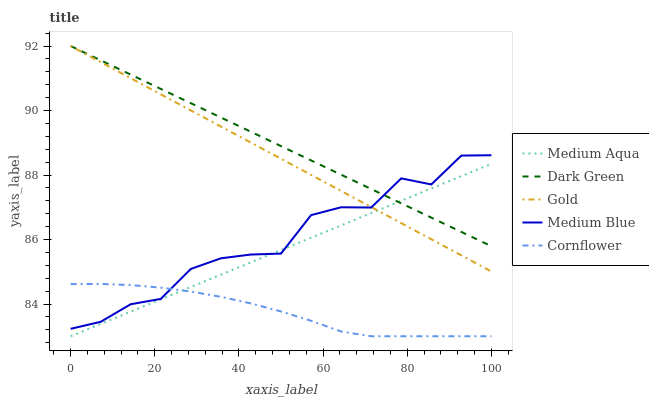Does Cornflower have the minimum area under the curve?
Answer yes or no. Yes. Does Dark Green have the maximum area under the curve?
Answer yes or no. Yes. Does Medium Aqua have the minimum area under the curve?
Answer yes or no. No. Does Medium Aqua have the maximum area under the curve?
Answer yes or no. No. Is Gold the smoothest?
Answer yes or no. Yes. Is Medium Blue the roughest?
Answer yes or no. Yes. Is Medium Aqua the smoothest?
Answer yes or no. No. Is Medium Aqua the roughest?
Answer yes or no. No. Does Medium Aqua have the lowest value?
Answer yes or no. Yes. Does Gold have the lowest value?
Answer yes or no. No. Does Dark Green have the highest value?
Answer yes or no. Yes. Does Medium Aqua have the highest value?
Answer yes or no. No. Is Cornflower less than Dark Green?
Answer yes or no. Yes. Is Gold greater than Cornflower?
Answer yes or no. Yes. Does Medium Aqua intersect Dark Green?
Answer yes or no. Yes. Is Medium Aqua less than Dark Green?
Answer yes or no. No. Is Medium Aqua greater than Dark Green?
Answer yes or no. No. Does Cornflower intersect Dark Green?
Answer yes or no. No. 